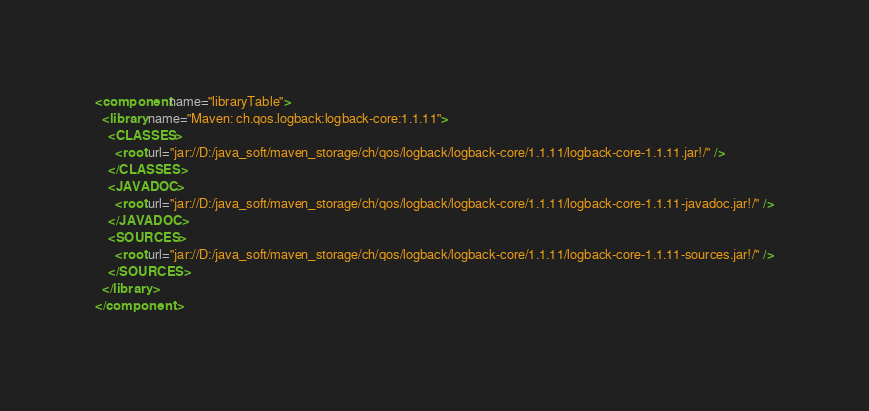Convert code to text. <code><loc_0><loc_0><loc_500><loc_500><_XML_><component name="libraryTable">
  <library name="Maven: ch.qos.logback:logback-core:1.1.11">
    <CLASSES>
      <root url="jar://D:/java_soft/maven_storage/ch/qos/logback/logback-core/1.1.11/logback-core-1.1.11.jar!/" />
    </CLASSES>
    <JAVADOC>
      <root url="jar://D:/java_soft/maven_storage/ch/qos/logback/logback-core/1.1.11/logback-core-1.1.11-javadoc.jar!/" />
    </JAVADOC>
    <SOURCES>
      <root url="jar://D:/java_soft/maven_storage/ch/qos/logback/logback-core/1.1.11/logback-core-1.1.11-sources.jar!/" />
    </SOURCES>
  </library>
</component></code> 